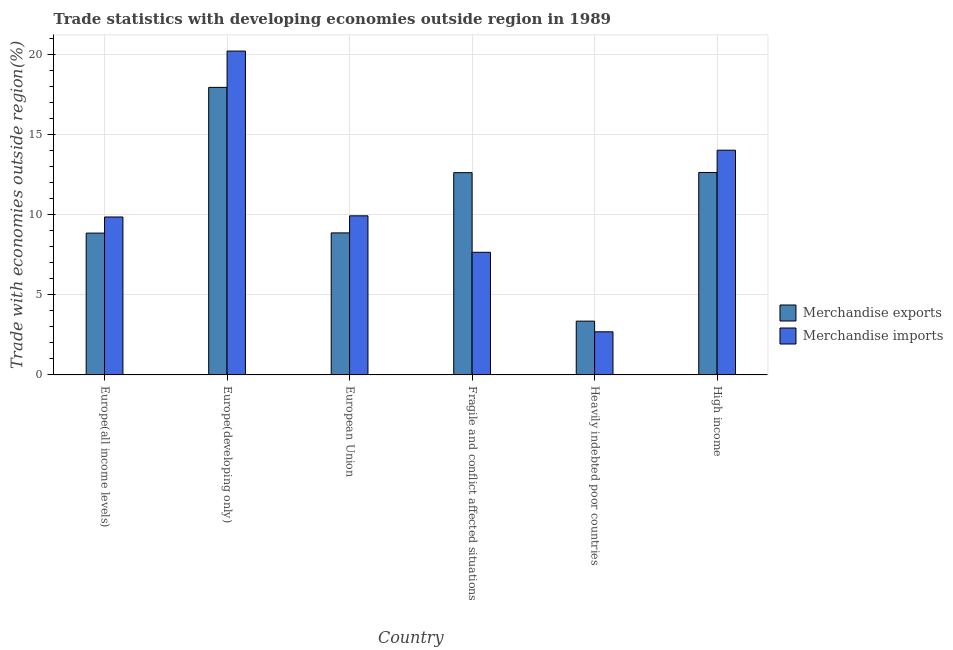How many different coloured bars are there?
Ensure brevity in your answer.  2. How many groups of bars are there?
Ensure brevity in your answer.  6. Are the number of bars per tick equal to the number of legend labels?
Ensure brevity in your answer.  Yes. What is the label of the 3rd group of bars from the left?
Provide a short and direct response. European Union. What is the merchandise imports in High income?
Offer a very short reply. 14.03. Across all countries, what is the maximum merchandise exports?
Provide a succinct answer. 17.95. Across all countries, what is the minimum merchandise exports?
Provide a short and direct response. 3.36. In which country was the merchandise imports maximum?
Make the answer very short. Europe(developing only). In which country was the merchandise exports minimum?
Offer a very short reply. Heavily indebted poor countries. What is the total merchandise imports in the graph?
Provide a short and direct response. 64.38. What is the difference between the merchandise exports in Fragile and conflict affected situations and that in High income?
Provide a succinct answer. -0.01. What is the difference between the merchandise exports in Europe(all income levels) and the merchandise imports in Europe(developing only)?
Your answer should be very brief. -11.36. What is the average merchandise imports per country?
Keep it short and to the point. 10.73. What is the difference between the merchandise imports and merchandise exports in High income?
Offer a terse response. 1.39. What is the ratio of the merchandise exports in Europe(all income levels) to that in Heavily indebted poor countries?
Your answer should be very brief. 2.64. Is the merchandise exports in Europe(all income levels) less than that in Heavily indebted poor countries?
Provide a succinct answer. No. Is the difference between the merchandise exports in Fragile and conflict affected situations and High income greater than the difference between the merchandise imports in Fragile and conflict affected situations and High income?
Your answer should be very brief. Yes. What is the difference between the highest and the second highest merchandise exports?
Offer a very short reply. 5.31. What is the difference between the highest and the lowest merchandise exports?
Offer a very short reply. 14.59. Is the sum of the merchandise imports in Europe(all income levels) and High income greater than the maximum merchandise exports across all countries?
Offer a very short reply. Yes. What does the 2nd bar from the left in Fragile and conflict affected situations represents?
Give a very brief answer. Merchandise imports. How many bars are there?
Provide a short and direct response. 12. Are the values on the major ticks of Y-axis written in scientific E-notation?
Your answer should be very brief. No. Does the graph contain grids?
Provide a short and direct response. Yes. Where does the legend appear in the graph?
Provide a succinct answer. Center right. How are the legend labels stacked?
Offer a terse response. Vertical. What is the title of the graph?
Provide a succinct answer. Trade statistics with developing economies outside region in 1989. What is the label or title of the X-axis?
Offer a very short reply. Country. What is the label or title of the Y-axis?
Keep it short and to the point. Trade with economies outside region(%). What is the Trade with economies outside region(%) of Merchandise exports in Europe(all income levels)?
Offer a very short reply. 8.85. What is the Trade with economies outside region(%) of Merchandise imports in Europe(all income levels)?
Your answer should be very brief. 9.86. What is the Trade with economies outside region(%) in Merchandise exports in Europe(developing only)?
Provide a succinct answer. 17.95. What is the Trade with economies outside region(%) of Merchandise imports in Europe(developing only)?
Offer a terse response. 20.22. What is the Trade with economies outside region(%) in Merchandise exports in European Union?
Ensure brevity in your answer.  8.87. What is the Trade with economies outside region(%) of Merchandise imports in European Union?
Offer a terse response. 9.93. What is the Trade with economies outside region(%) of Merchandise exports in Fragile and conflict affected situations?
Keep it short and to the point. 12.63. What is the Trade with economies outside region(%) in Merchandise imports in Fragile and conflict affected situations?
Ensure brevity in your answer.  7.66. What is the Trade with economies outside region(%) of Merchandise exports in Heavily indebted poor countries?
Your answer should be very brief. 3.36. What is the Trade with economies outside region(%) of Merchandise imports in Heavily indebted poor countries?
Give a very brief answer. 2.69. What is the Trade with economies outside region(%) in Merchandise exports in High income?
Offer a terse response. 12.64. What is the Trade with economies outside region(%) of Merchandise imports in High income?
Offer a very short reply. 14.03. Across all countries, what is the maximum Trade with economies outside region(%) of Merchandise exports?
Provide a short and direct response. 17.95. Across all countries, what is the maximum Trade with economies outside region(%) of Merchandise imports?
Your response must be concise. 20.22. Across all countries, what is the minimum Trade with economies outside region(%) in Merchandise exports?
Offer a very short reply. 3.36. Across all countries, what is the minimum Trade with economies outside region(%) of Merchandise imports?
Give a very brief answer. 2.69. What is the total Trade with economies outside region(%) in Merchandise exports in the graph?
Your answer should be very brief. 64.29. What is the total Trade with economies outside region(%) of Merchandise imports in the graph?
Offer a terse response. 64.38. What is the difference between the Trade with economies outside region(%) in Merchandise exports in Europe(all income levels) and that in Europe(developing only)?
Offer a very short reply. -9.1. What is the difference between the Trade with economies outside region(%) in Merchandise imports in Europe(all income levels) and that in Europe(developing only)?
Keep it short and to the point. -10.36. What is the difference between the Trade with economies outside region(%) in Merchandise exports in Europe(all income levels) and that in European Union?
Provide a succinct answer. -0.01. What is the difference between the Trade with economies outside region(%) of Merchandise imports in Europe(all income levels) and that in European Union?
Your answer should be very brief. -0.07. What is the difference between the Trade with economies outside region(%) in Merchandise exports in Europe(all income levels) and that in Fragile and conflict affected situations?
Your response must be concise. -3.77. What is the difference between the Trade with economies outside region(%) of Merchandise imports in Europe(all income levels) and that in Fragile and conflict affected situations?
Make the answer very short. 2.2. What is the difference between the Trade with economies outside region(%) of Merchandise exports in Europe(all income levels) and that in Heavily indebted poor countries?
Offer a very short reply. 5.49. What is the difference between the Trade with economies outside region(%) of Merchandise imports in Europe(all income levels) and that in Heavily indebted poor countries?
Ensure brevity in your answer.  7.17. What is the difference between the Trade with economies outside region(%) in Merchandise exports in Europe(all income levels) and that in High income?
Your answer should be compact. -3.78. What is the difference between the Trade with economies outside region(%) in Merchandise imports in Europe(all income levels) and that in High income?
Keep it short and to the point. -4.17. What is the difference between the Trade with economies outside region(%) of Merchandise exports in Europe(developing only) and that in European Union?
Give a very brief answer. 9.08. What is the difference between the Trade with economies outside region(%) of Merchandise imports in Europe(developing only) and that in European Union?
Provide a succinct answer. 10.28. What is the difference between the Trade with economies outside region(%) of Merchandise exports in Europe(developing only) and that in Fragile and conflict affected situations?
Make the answer very short. 5.32. What is the difference between the Trade with economies outside region(%) in Merchandise imports in Europe(developing only) and that in Fragile and conflict affected situations?
Offer a very short reply. 12.56. What is the difference between the Trade with economies outside region(%) in Merchandise exports in Europe(developing only) and that in Heavily indebted poor countries?
Ensure brevity in your answer.  14.59. What is the difference between the Trade with economies outside region(%) in Merchandise imports in Europe(developing only) and that in Heavily indebted poor countries?
Offer a terse response. 17.53. What is the difference between the Trade with economies outside region(%) of Merchandise exports in Europe(developing only) and that in High income?
Your answer should be very brief. 5.31. What is the difference between the Trade with economies outside region(%) of Merchandise imports in Europe(developing only) and that in High income?
Your response must be concise. 6.19. What is the difference between the Trade with economies outside region(%) in Merchandise exports in European Union and that in Fragile and conflict affected situations?
Give a very brief answer. -3.76. What is the difference between the Trade with economies outside region(%) in Merchandise imports in European Union and that in Fragile and conflict affected situations?
Give a very brief answer. 2.28. What is the difference between the Trade with economies outside region(%) in Merchandise exports in European Union and that in Heavily indebted poor countries?
Offer a very short reply. 5.51. What is the difference between the Trade with economies outside region(%) in Merchandise imports in European Union and that in Heavily indebted poor countries?
Ensure brevity in your answer.  7.24. What is the difference between the Trade with economies outside region(%) in Merchandise exports in European Union and that in High income?
Your answer should be very brief. -3.77. What is the difference between the Trade with economies outside region(%) in Merchandise imports in European Union and that in High income?
Provide a short and direct response. -4.1. What is the difference between the Trade with economies outside region(%) of Merchandise exports in Fragile and conflict affected situations and that in Heavily indebted poor countries?
Provide a succinct answer. 9.27. What is the difference between the Trade with economies outside region(%) of Merchandise imports in Fragile and conflict affected situations and that in Heavily indebted poor countries?
Provide a succinct answer. 4.96. What is the difference between the Trade with economies outside region(%) of Merchandise exports in Fragile and conflict affected situations and that in High income?
Offer a terse response. -0.01. What is the difference between the Trade with economies outside region(%) of Merchandise imports in Fragile and conflict affected situations and that in High income?
Your answer should be compact. -6.37. What is the difference between the Trade with economies outside region(%) of Merchandise exports in Heavily indebted poor countries and that in High income?
Keep it short and to the point. -9.28. What is the difference between the Trade with economies outside region(%) of Merchandise imports in Heavily indebted poor countries and that in High income?
Offer a terse response. -11.34. What is the difference between the Trade with economies outside region(%) of Merchandise exports in Europe(all income levels) and the Trade with economies outside region(%) of Merchandise imports in Europe(developing only)?
Keep it short and to the point. -11.36. What is the difference between the Trade with economies outside region(%) in Merchandise exports in Europe(all income levels) and the Trade with economies outside region(%) in Merchandise imports in European Union?
Provide a short and direct response. -1.08. What is the difference between the Trade with economies outside region(%) of Merchandise exports in Europe(all income levels) and the Trade with economies outside region(%) of Merchandise imports in Fragile and conflict affected situations?
Offer a very short reply. 1.2. What is the difference between the Trade with economies outside region(%) of Merchandise exports in Europe(all income levels) and the Trade with economies outside region(%) of Merchandise imports in Heavily indebted poor countries?
Ensure brevity in your answer.  6.16. What is the difference between the Trade with economies outside region(%) in Merchandise exports in Europe(all income levels) and the Trade with economies outside region(%) in Merchandise imports in High income?
Offer a terse response. -5.18. What is the difference between the Trade with economies outside region(%) in Merchandise exports in Europe(developing only) and the Trade with economies outside region(%) in Merchandise imports in European Union?
Provide a short and direct response. 8.02. What is the difference between the Trade with economies outside region(%) in Merchandise exports in Europe(developing only) and the Trade with economies outside region(%) in Merchandise imports in Fragile and conflict affected situations?
Give a very brief answer. 10.29. What is the difference between the Trade with economies outside region(%) in Merchandise exports in Europe(developing only) and the Trade with economies outside region(%) in Merchandise imports in Heavily indebted poor countries?
Your answer should be compact. 15.26. What is the difference between the Trade with economies outside region(%) of Merchandise exports in Europe(developing only) and the Trade with economies outside region(%) of Merchandise imports in High income?
Ensure brevity in your answer.  3.92. What is the difference between the Trade with economies outside region(%) in Merchandise exports in European Union and the Trade with economies outside region(%) in Merchandise imports in Fragile and conflict affected situations?
Keep it short and to the point. 1.21. What is the difference between the Trade with economies outside region(%) of Merchandise exports in European Union and the Trade with economies outside region(%) of Merchandise imports in Heavily indebted poor countries?
Keep it short and to the point. 6.17. What is the difference between the Trade with economies outside region(%) in Merchandise exports in European Union and the Trade with economies outside region(%) in Merchandise imports in High income?
Give a very brief answer. -5.16. What is the difference between the Trade with economies outside region(%) in Merchandise exports in Fragile and conflict affected situations and the Trade with economies outside region(%) in Merchandise imports in Heavily indebted poor countries?
Give a very brief answer. 9.93. What is the difference between the Trade with economies outside region(%) in Merchandise exports in Fragile and conflict affected situations and the Trade with economies outside region(%) in Merchandise imports in High income?
Provide a succinct answer. -1.4. What is the difference between the Trade with economies outside region(%) of Merchandise exports in Heavily indebted poor countries and the Trade with economies outside region(%) of Merchandise imports in High income?
Provide a short and direct response. -10.67. What is the average Trade with economies outside region(%) in Merchandise exports per country?
Keep it short and to the point. 10.71. What is the average Trade with economies outside region(%) in Merchandise imports per country?
Ensure brevity in your answer.  10.73. What is the difference between the Trade with economies outside region(%) in Merchandise exports and Trade with economies outside region(%) in Merchandise imports in Europe(all income levels)?
Your answer should be compact. -1.01. What is the difference between the Trade with economies outside region(%) in Merchandise exports and Trade with economies outside region(%) in Merchandise imports in Europe(developing only)?
Offer a terse response. -2.27. What is the difference between the Trade with economies outside region(%) in Merchandise exports and Trade with economies outside region(%) in Merchandise imports in European Union?
Offer a very short reply. -1.07. What is the difference between the Trade with economies outside region(%) of Merchandise exports and Trade with economies outside region(%) of Merchandise imports in Fragile and conflict affected situations?
Provide a succinct answer. 4.97. What is the difference between the Trade with economies outside region(%) of Merchandise exports and Trade with economies outside region(%) of Merchandise imports in Heavily indebted poor countries?
Offer a very short reply. 0.67. What is the difference between the Trade with economies outside region(%) of Merchandise exports and Trade with economies outside region(%) of Merchandise imports in High income?
Give a very brief answer. -1.39. What is the ratio of the Trade with economies outside region(%) in Merchandise exports in Europe(all income levels) to that in Europe(developing only)?
Provide a succinct answer. 0.49. What is the ratio of the Trade with economies outside region(%) of Merchandise imports in Europe(all income levels) to that in Europe(developing only)?
Make the answer very short. 0.49. What is the ratio of the Trade with economies outside region(%) of Merchandise imports in Europe(all income levels) to that in European Union?
Your answer should be compact. 0.99. What is the ratio of the Trade with economies outside region(%) in Merchandise exports in Europe(all income levels) to that in Fragile and conflict affected situations?
Provide a succinct answer. 0.7. What is the ratio of the Trade with economies outside region(%) in Merchandise imports in Europe(all income levels) to that in Fragile and conflict affected situations?
Offer a terse response. 1.29. What is the ratio of the Trade with economies outside region(%) in Merchandise exports in Europe(all income levels) to that in Heavily indebted poor countries?
Provide a succinct answer. 2.64. What is the ratio of the Trade with economies outside region(%) in Merchandise imports in Europe(all income levels) to that in Heavily indebted poor countries?
Offer a terse response. 3.66. What is the ratio of the Trade with economies outside region(%) in Merchandise exports in Europe(all income levels) to that in High income?
Make the answer very short. 0.7. What is the ratio of the Trade with economies outside region(%) of Merchandise imports in Europe(all income levels) to that in High income?
Keep it short and to the point. 0.7. What is the ratio of the Trade with economies outside region(%) in Merchandise exports in Europe(developing only) to that in European Union?
Make the answer very short. 2.02. What is the ratio of the Trade with economies outside region(%) in Merchandise imports in Europe(developing only) to that in European Union?
Your answer should be compact. 2.04. What is the ratio of the Trade with economies outside region(%) in Merchandise exports in Europe(developing only) to that in Fragile and conflict affected situations?
Keep it short and to the point. 1.42. What is the ratio of the Trade with economies outside region(%) in Merchandise imports in Europe(developing only) to that in Fragile and conflict affected situations?
Keep it short and to the point. 2.64. What is the ratio of the Trade with economies outside region(%) in Merchandise exports in Europe(developing only) to that in Heavily indebted poor countries?
Provide a short and direct response. 5.35. What is the ratio of the Trade with economies outside region(%) in Merchandise imports in Europe(developing only) to that in Heavily indebted poor countries?
Ensure brevity in your answer.  7.51. What is the ratio of the Trade with economies outside region(%) of Merchandise exports in Europe(developing only) to that in High income?
Give a very brief answer. 1.42. What is the ratio of the Trade with economies outside region(%) of Merchandise imports in Europe(developing only) to that in High income?
Provide a short and direct response. 1.44. What is the ratio of the Trade with economies outside region(%) in Merchandise exports in European Union to that in Fragile and conflict affected situations?
Keep it short and to the point. 0.7. What is the ratio of the Trade with economies outside region(%) of Merchandise imports in European Union to that in Fragile and conflict affected situations?
Your answer should be compact. 1.3. What is the ratio of the Trade with economies outside region(%) of Merchandise exports in European Union to that in Heavily indebted poor countries?
Ensure brevity in your answer.  2.64. What is the ratio of the Trade with economies outside region(%) of Merchandise imports in European Union to that in Heavily indebted poor countries?
Keep it short and to the point. 3.69. What is the ratio of the Trade with economies outside region(%) of Merchandise exports in European Union to that in High income?
Offer a very short reply. 0.7. What is the ratio of the Trade with economies outside region(%) in Merchandise imports in European Union to that in High income?
Make the answer very short. 0.71. What is the ratio of the Trade with economies outside region(%) in Merchandise exports in Fragile and conflict affected situations to that in Heavily indebted poor countries?
Make the answer very short. 3.76. What is the ratio of the Trade with economies outside region(%) of Merchandise imports in Fragile and conflict affected situations to that in Heavily indebted poor countries?
Your answer should be compact. 2.84. What is the ratio of the Trade with economies outside region(%) of Merchandise exports in Fragile and conflict affected situations to that in High income?
Offer a terse response. 1. What is the ratio of the Trade with economies outside region(%) of Merchandise imports in Fragile and conflict affected situations to that in High income?
Ensure brevity in your answer.  0.55. What is the ratio of the Trade with economies outside region(%) of Merchandise exports in Heavily indebted poor countries to that in High income?
Make the answer very short. 0.27. What is the ratio of the Trade with economies outside region(%) of Merchandise imports in Heavily indebted poor countries to that in High income?
Give a very brief answer. 0.19. What is the difference between the highest and the second highest Trade with economies outside region(%) in Merchandise exports?
Ensure brevity in your answer.  5.31. What is the difference between the highest and the second highest Trade with economies outside region(%) of Merchandise imports?
Provide a succinct answer. 6.19. What is the difference between the highest and the lowest Trade with economies outside region(%) of Merchandise exports?
Ensure brevity in your answer.  14.59. What is the difference between the highest and the lowest Trade with economies outside region(%) of Merchandise imports?
Provide a short and direct response. 17.53. 